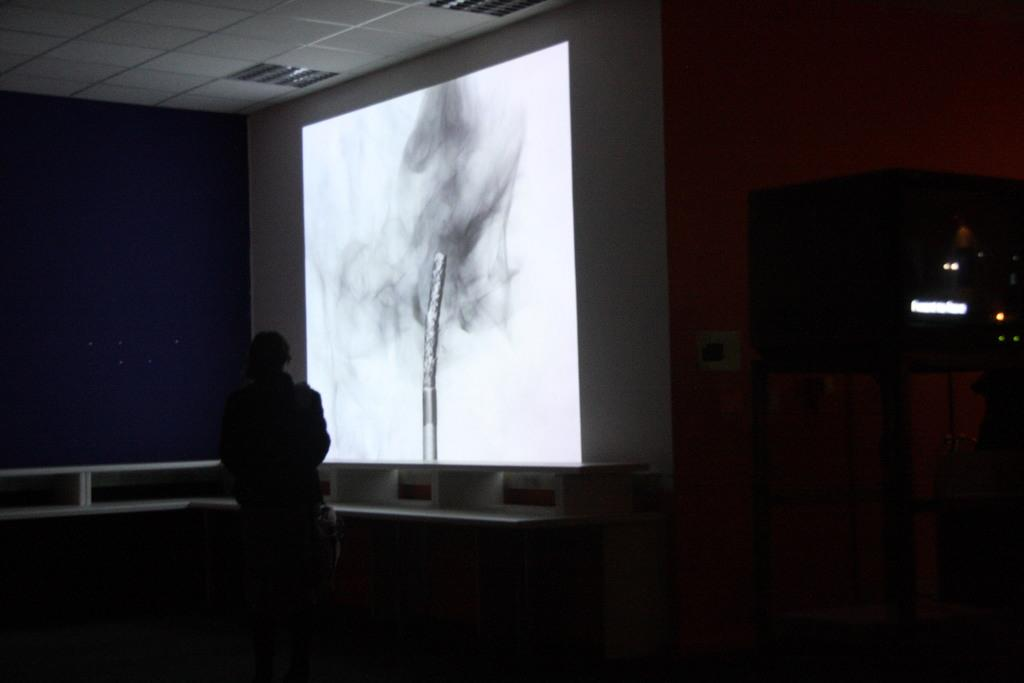What is the main subject of the image? There is a person standing in the middle of the image. What is the person doing in the image? The person is looking at a projected image. What type of camp can be seen in the background of the image? There is no camp present in the image; it only features a person looking at a projected image. How many circles are visible in the image? There is no mention of circles in the image, so it is not possible to determine their presence or quantity. 